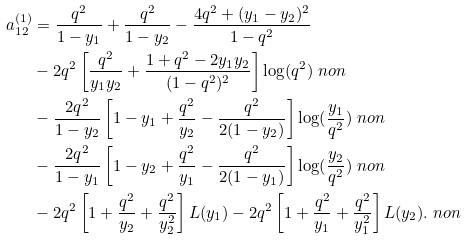<formula> <loc_0><loc_0><loc_500><loc_500>a _ { 1 2 } ^ { ( 1 ) } & = \frac { q ^ { 2 } } { 1 - y _ { 1 } } + \frac { q ^ { 2 } } { 1 - y _ { 2 } } - \frac { 4 q ^ { 2 } + ( y _ { 1 } - y _ { 2 } ) ^ { 2 } } { 1 - q ^ { 2 } } \\ & - 2 q ^ { 2 } \left [ \frac { q ^ { 2 } } { y _ { 1 } y _ { 2 } } + \frac { 1 + q ^ { 2 } - 2 y _ { 1 } y _ { 2 } } { ( 1 - q ^ { 2 } ) ^ { 2 } } \right ] \log ( q ^ { 2 } ) \ n o n \\ & - \frac { 2 q ^ { 2 } } { 1 - y _ { 2 } } \left [ 1 - y _ { 1 } + \frac { q ^ { 2 } } { y _ { 2 } } - \frac { q ^ { 2 } } { 2 ( 1 - y _ { 2 } ) } \right ] \log ( \frac { y _ { 1 } } { q ^ { 2 } } ) \ n o n \\ & - \frac { 2 q ^ { 2 } } { 1 - y _ { 1 } } \left [ 1 - y _ { 2 } + \frac { q ^ { 2 } } { y _ { 1 } } - \frac { q ^ { 2 } } { 2 ( 1 - y _ { 1 } ) } \right ] \log ( \frac { y _ { 2 } } { q ^ { 2 } } ) \ n o n \\ & - 2 q ^ { 2 } \left [ 1 + \frac { q ^ { 2 } } { y _ { 2 } } + \frac { q ^ { 2 } } { y _ { 2 } ^ { 2 } } \right ] L ( y _ { 1 } ) - 2 q ^ { 2 } \left [ 1 + \frac { q ^ { 2 } } { y _ { 1 } } + \frac { q ^ { 2 } } { y _ { 1 } ^ { 2 } } \right ] L ( y _ { 2 } ) . \ n o n</formula> 